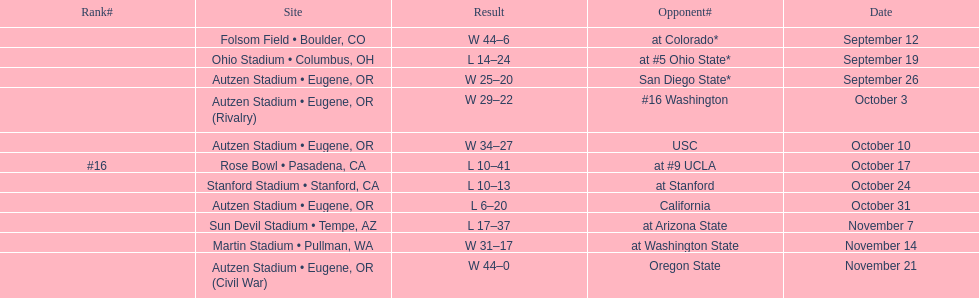What is the quantity of away games? 6. 